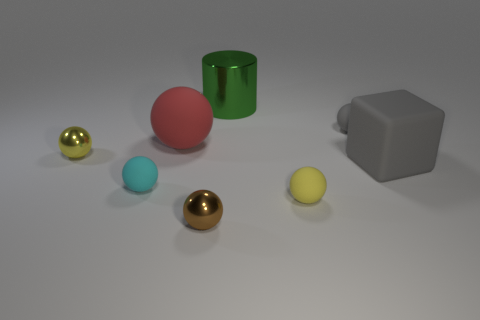Do the large green cylinder and the large red ball have the same material?
Offer a very short reply. No. What shape is the matte object on the right side of the small object behind the yellow thing that is behind the gray cube?
Your response must be concise. Cube. Is the number of red things behind the red matte thing less than the number of small matte balls in front of the gray matte ball?
Offer a very short reply. Yes. The red rubber object behind the yellow thing that is in front of the yellow metallic ball is what shape?
Your answer should be very brief. Sphere. Is there anything else of the same color as the large sphere?
Your response must be concise. No. Do the shiny cylinder and the large rubber ball have the same color?
Keep it short and to the point. No. What number of gray things are spheres or large cylinders?
Your answer should be compact. 1. Are there fewer tiny gray things that are in front of the brown object than large gray rubber blocks?
Provide a short and direct response. Yes. There is a tiny yellow sphere to the left of the large red rubber ball; how many cyan things are on the left side of it?
Give a very brief answer. 0. What number of other objects are the same size as the cyan thing?
Provide a succinct answer. 4. 